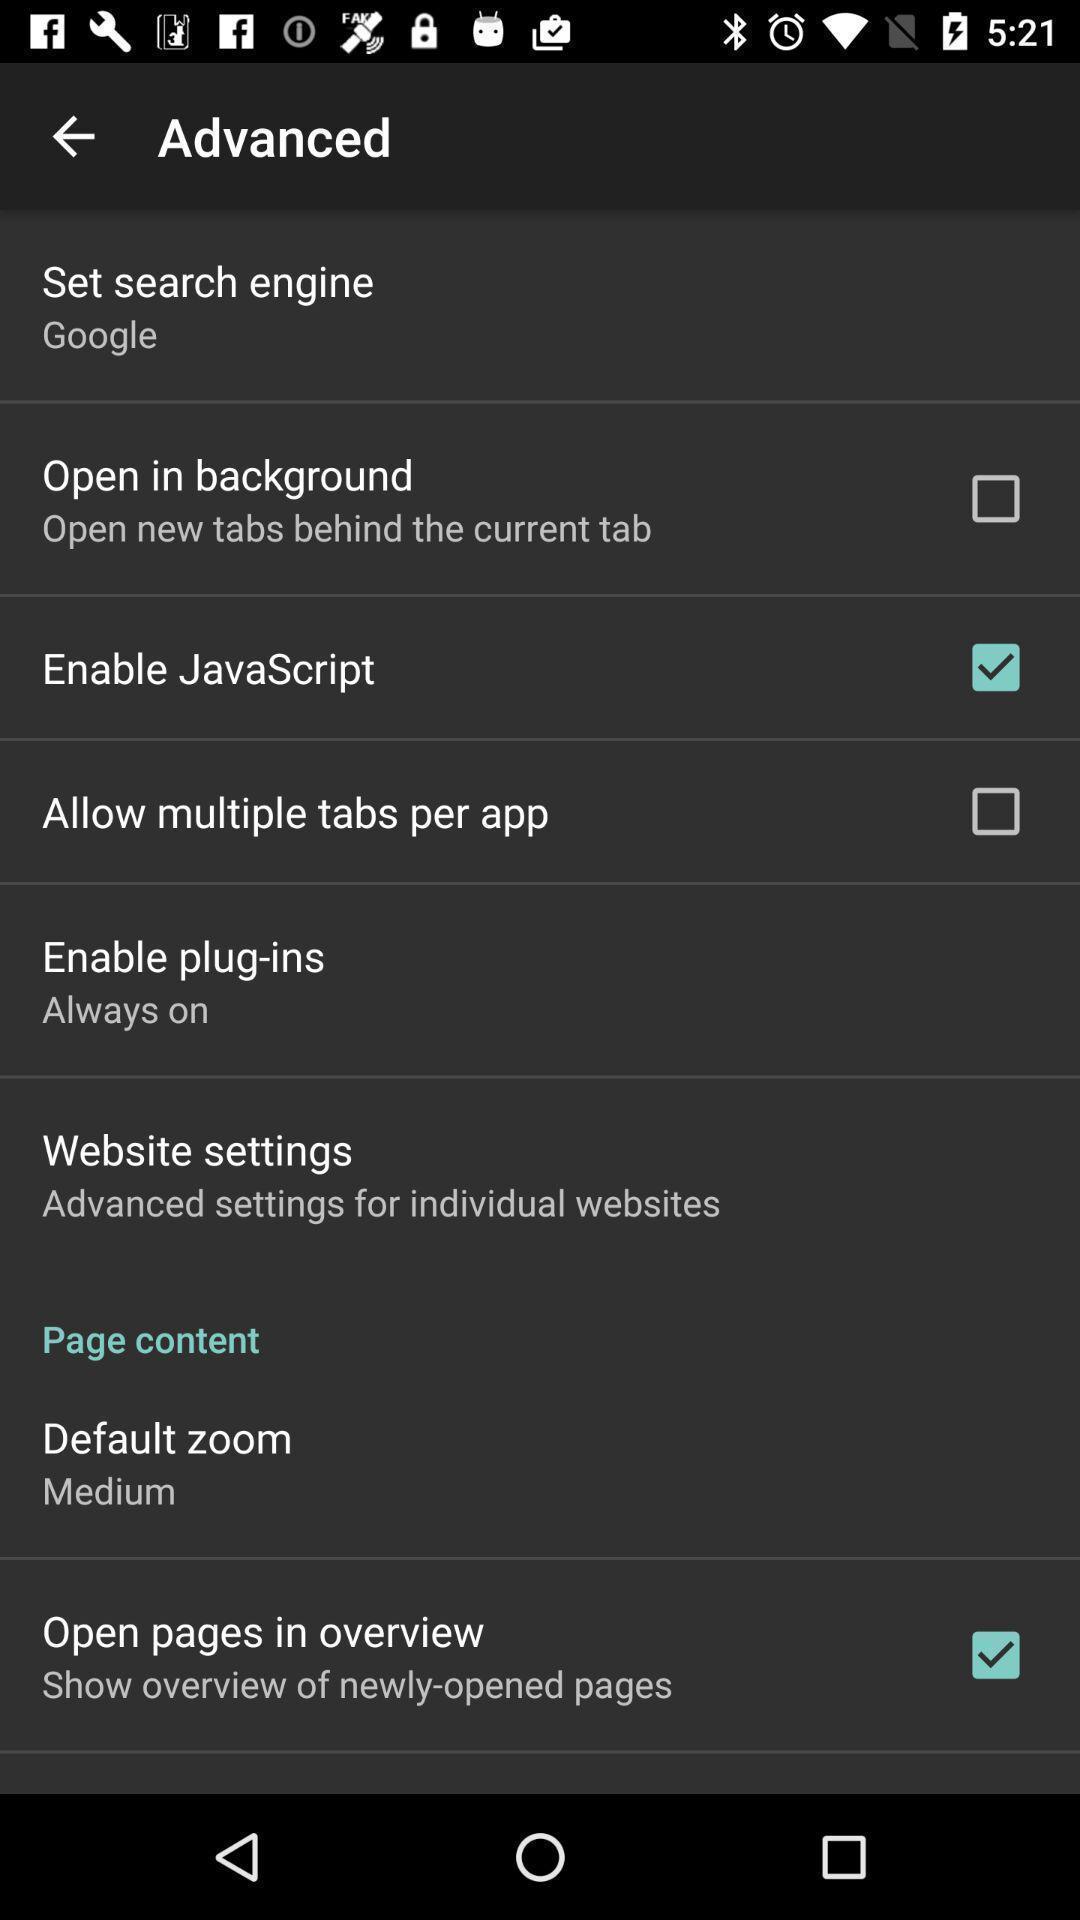Give me a narrative description of this picture. Page showing different options. 